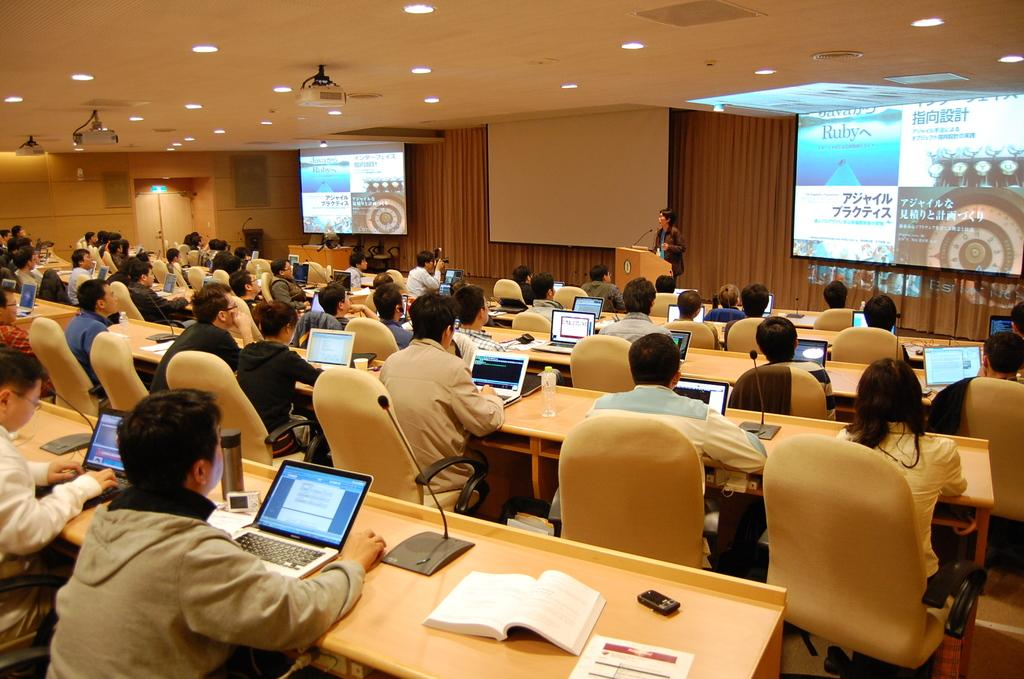What is the main object in the image? There is a screen in the image. What are the people in the image doing? The people are sitting on chairs in the image. What is on the table in the image? There is a laptop, a microphone (mic), a mobile phone, and books on the table. What time of day is it in the image? The provided facts do not mention the time of day. --- Facts: 1. There is a car in the image. 2. The car is red. 3. The car has four wheels. 4. The car has a sunroof. 5. The car has a rear spoiler. Absurd Topics: rainbow Conversation: What is the main subject in the image? There is a car in the image. What color is the car? The car is red. How many wheels does the car have? The car has four wheels. What additional feature does the car have? The car has a sunroof. What other feature does the car have? The car has a rear spoiler. Reasoning: Let's think step by step in order to produce the conversation. We start by identifying the main subject of the image, which is the car. Next, we describe specific features of the car, such as its color, the number of wheels, and the presence of a sunroof and a rear spoiler. Each question is designed to elicit a specific detail about the car that is known from the provided facts. Absurd Question/Answer: What type of rainbow can be seen in the image? There is no mention of a rainbow in the provided facts. 